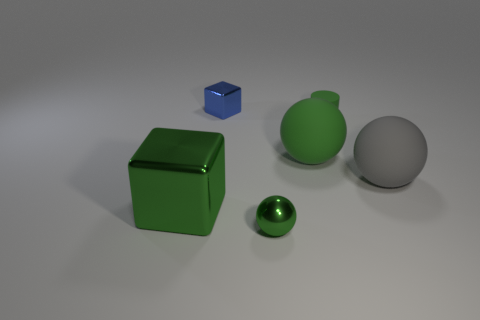Add 4 tiny red rubber balls. How many objects exist? 10 Subtract all cubes. How many objects are left? 4 Add 2 small blocks. How many small blocks are left? 3 Add 2 small purple rubber objects. How many small purple rubber objects exist? 2 Subtract 1 green cylinders. How many objects are left? 5 Subtract all shiny spheres. Subtract all brown cylinders. How many objects are left? 5 